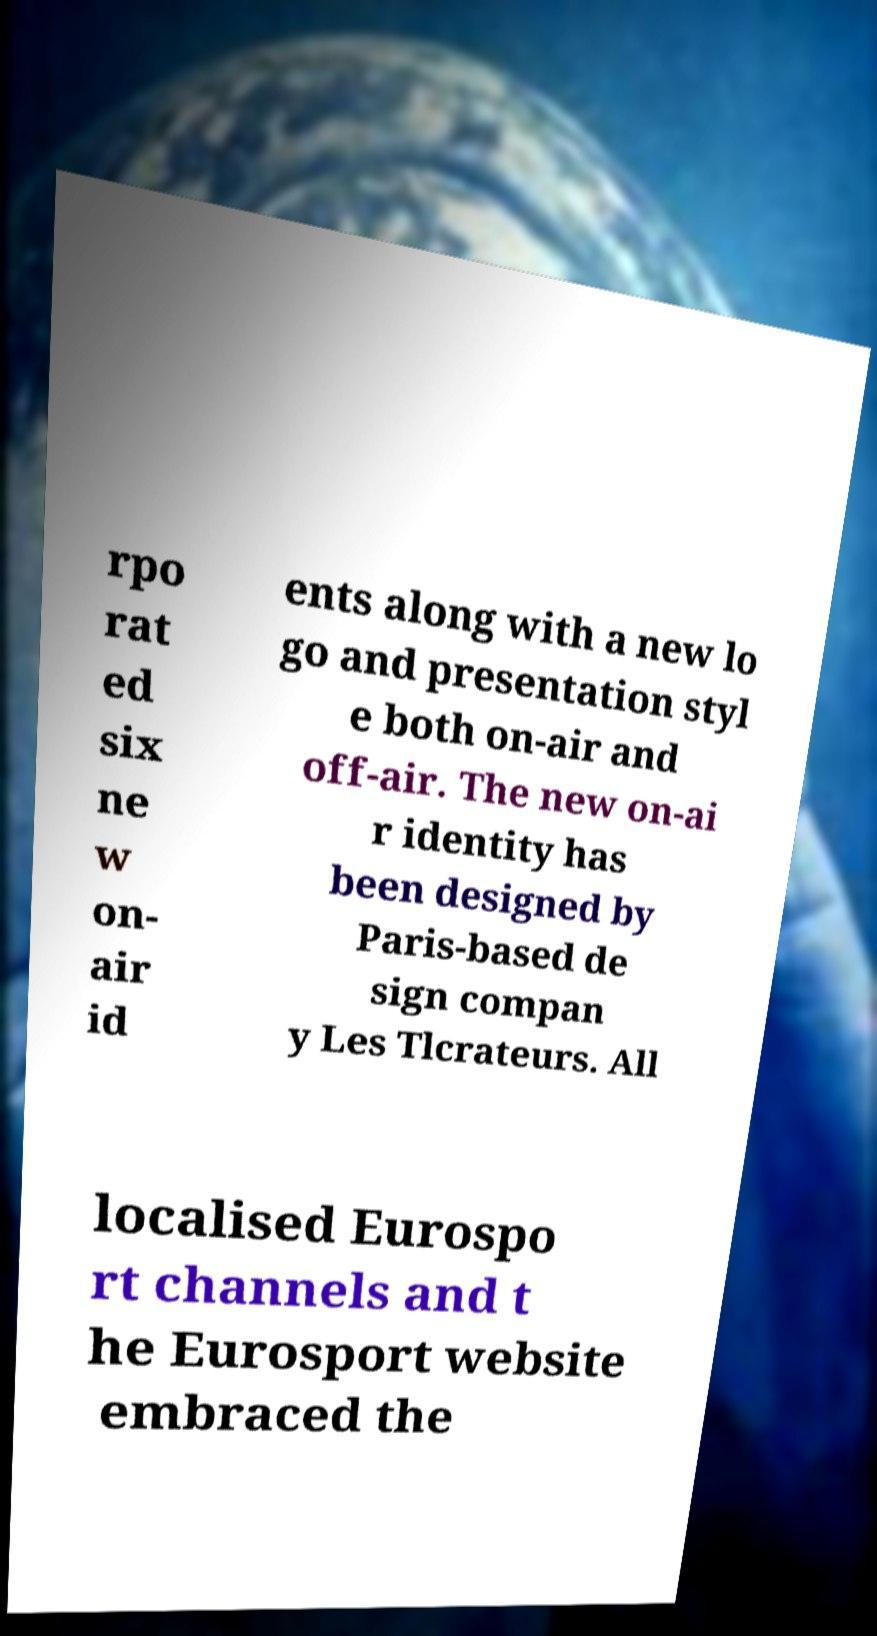Could you extract and type out the text from this image? rpo rat ed six ne w on- air id ents along with a new lo go and presentation styl e both on-air and off-air. The new on-ai r identity has been designed by Paris-based de sign compan y Les Tlcrateurs. All localised Eurospo rt channels and t he Eurosport website embraced the 